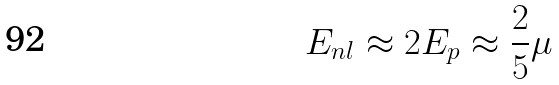<formula> <loc_0><loc_0><loc_500><loc_500>E _ { n l } \approx 2 E _ { p } \approx \frac { 2 } { 5 } \mu</formula> 